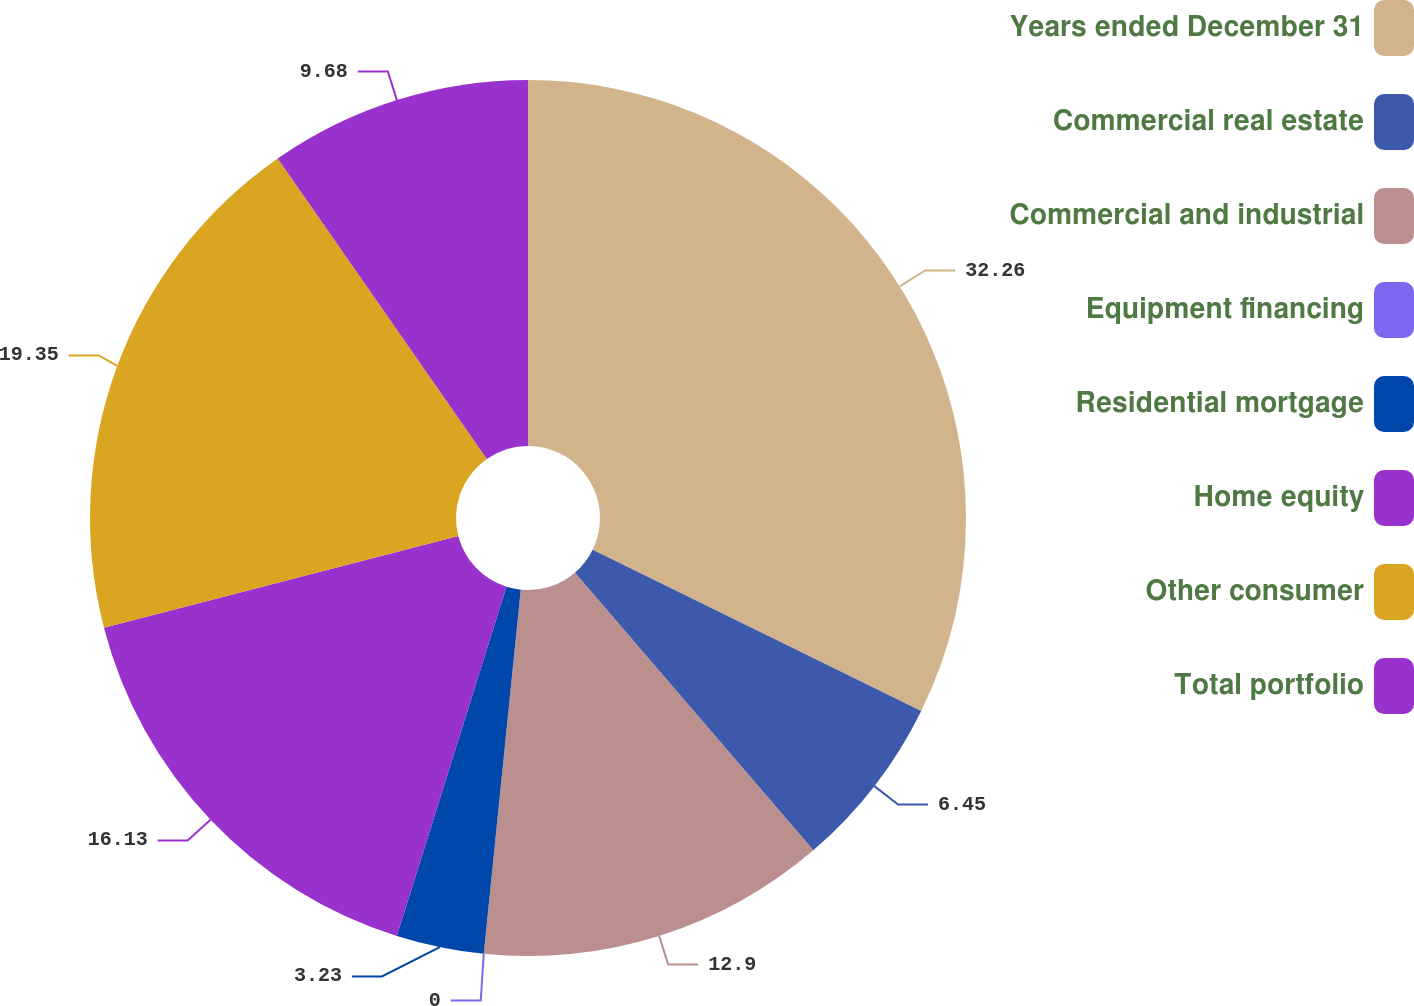Convert chart. <chart><loc_0><loc_0><loc_500><loc_500><pie_chart><fcel>Years ended December 31<fcel>Commercial real estate<fcel>Commercial and industrial<fcel>Equipment financing<fcel>Residential mortgage<fcel>Home equity<fcel>Other consumer<fcel>Total portfolio<nl><fcel>32.26%<fcel>6.45%<fcel>12.9%<fcel>0.0%<fcel>3.23%<fcel>16.13%<fcel>19.35%<fcel>9.68%<nl></chart> 